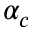Convert formula to latex. <formula><loc_0><loc_0><loc_500><loc_500>\alpha _ { c }</formula> 